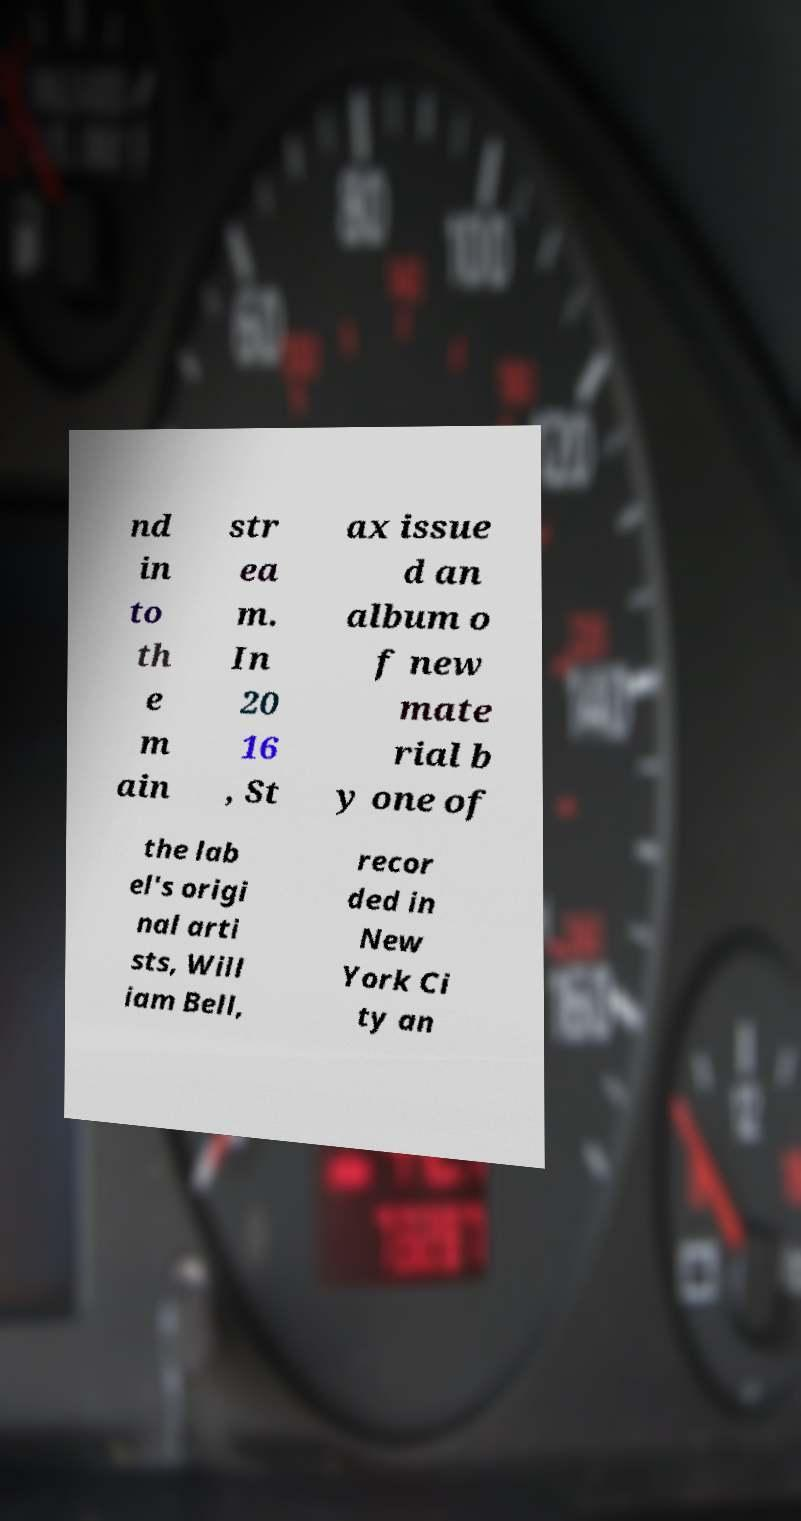There's text embedded in this image that I need extracted. Can you transcribe it verbatim? nd in to th e m ain str ea m. In 20 16 , St ax issue d an album o f new mate rial b y one of the lab el's origi nal arti sts, Will iam Bell, recor ded in New York Ci ty an 